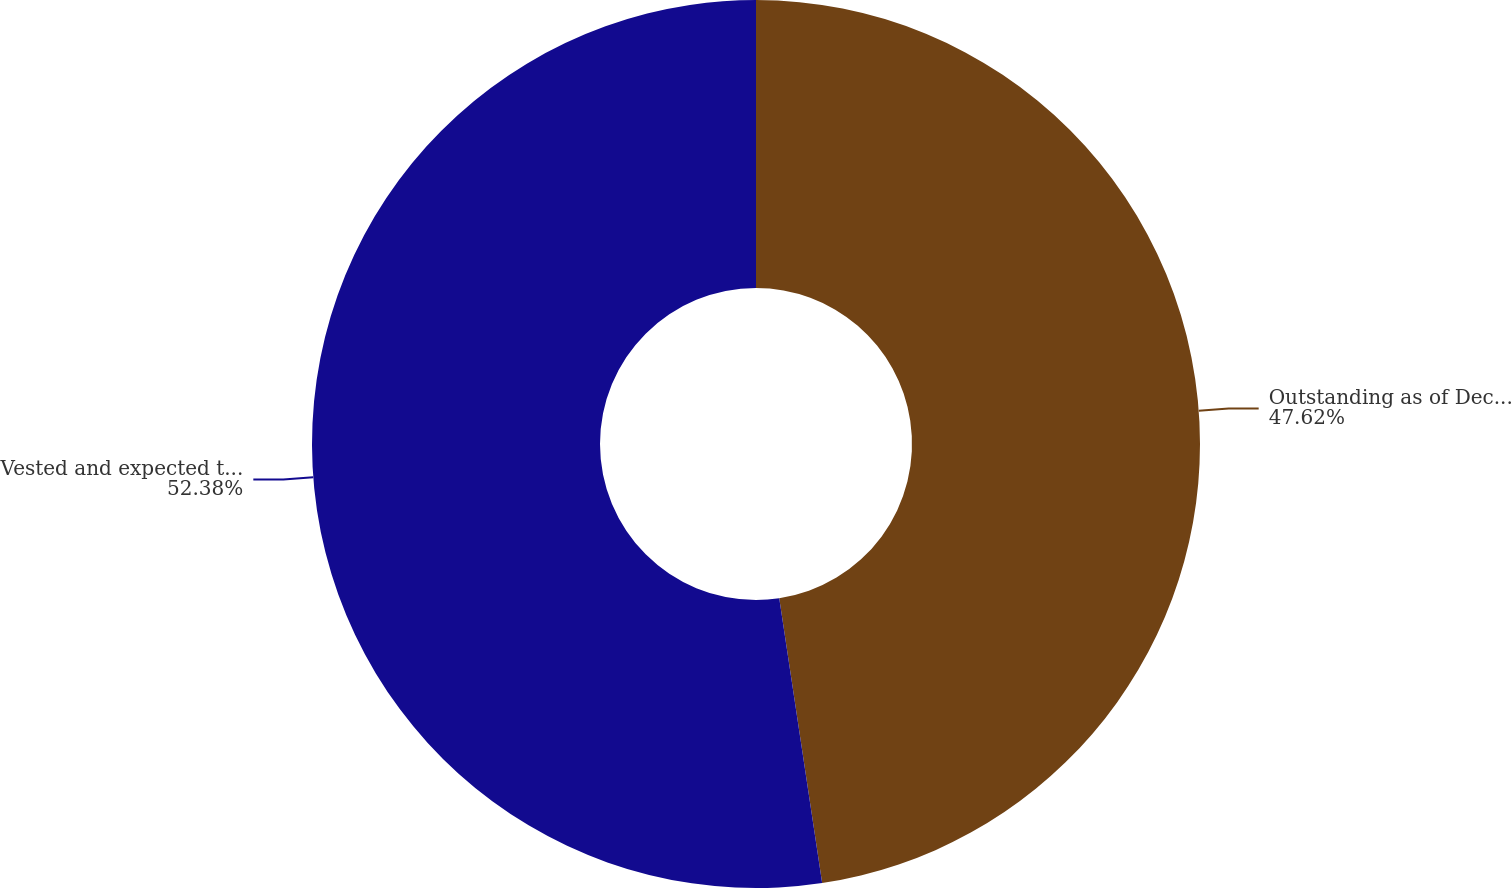Convert chart to OTSL. <chart><loc_0><loc_0><loc_500><loc_500><pie_chart><fcel>Outstanding as of December 31<fcel>Vested and expected to vest as<nl><fcel>47.62%<fcel>52.38%<nl></chart> 